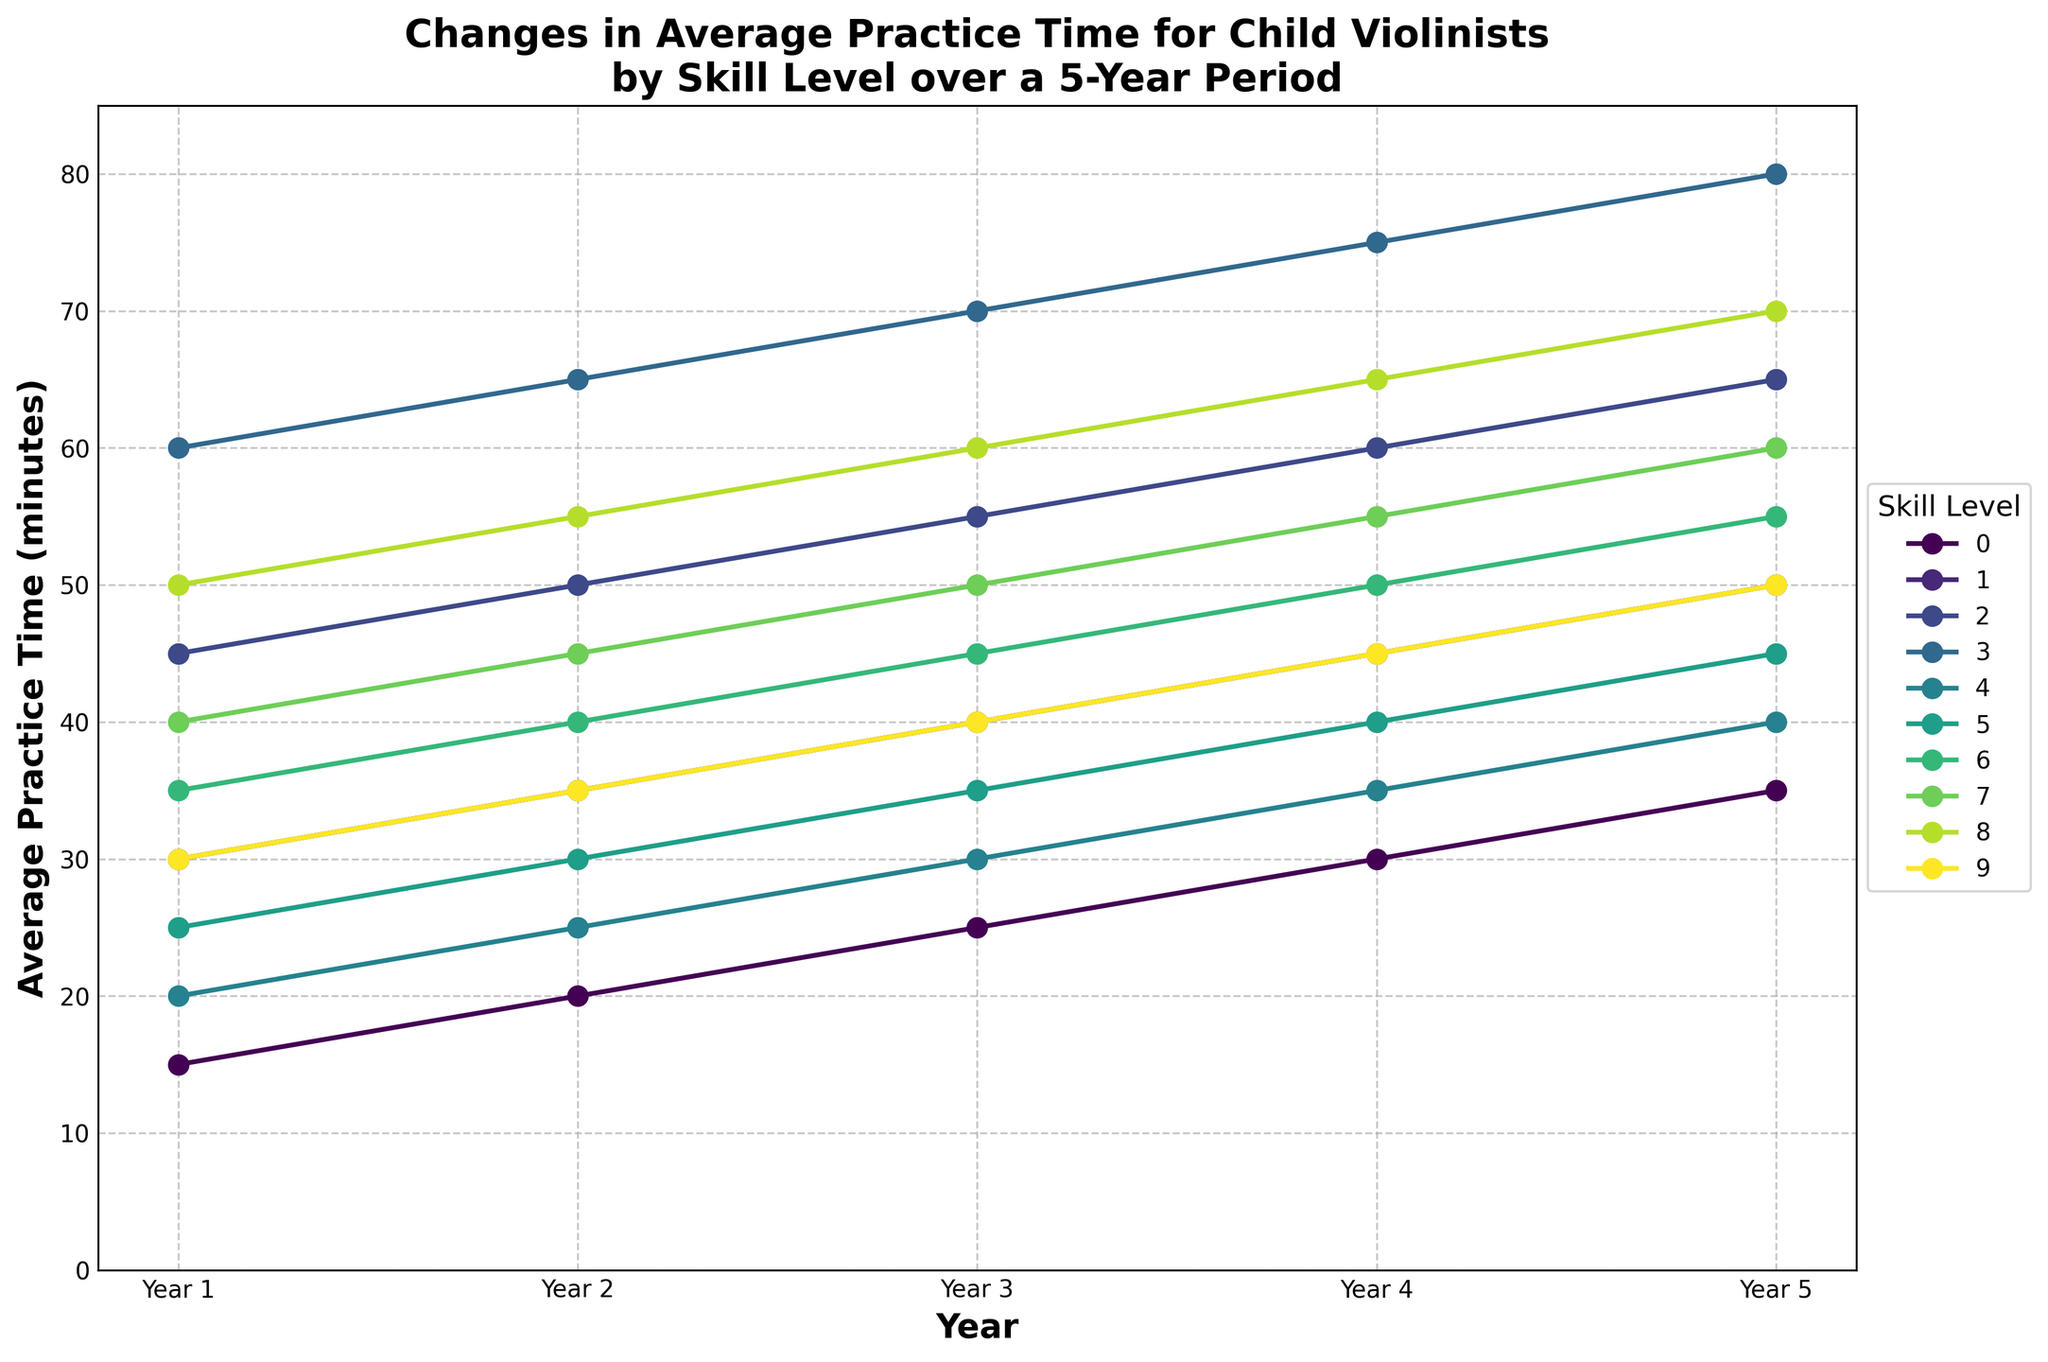What skill level has the steepest increase in practice time over the 5 years? Identify the skill level with the highest difference between the 5th and 1st years. Pre-Professional increases by 20 (from 60 to 80), which is the steepest.
Answer: Pre-Professional Which year shows the largest collective increase in practice time across all levels from the previous year? Calculate the increase for each year across all levels and compare. Year 2 shows the sums of increases: (20-15) + (35-30) + (50-45) + (65-60) + (25-20) + (30-25) + (40-35) + (45-40) + (55-50) + (35-30) = 5 + 5 + 5 + 5 + 5 + 5 + 5 + 5 + 5 + 5 = 50 minutes total, which is the largest.
Answer: Year 2 How does the practice time of a Duet Partner in Year 3 compare to that of an Intermediate-level violinist in Year 5? Look at the practice times for the Duet Partner in Year 3 (40 minutes) and Intermediate-level in Year 5 (50 minutes). Compare 40 to 50.
Answer: Less What is the average practice time for all skill levels in Year 1? Sum all practice times in Year 1 and divide by the number of skill levels (10). (15 + 30 + 45 + 60 + 20 + 25 + 35 + 40 + 50 + 30) / 10 = 35.
Answer: 35 minutes Which skill level had the smallest change in practice time over the 5-year period? Find the difference between the 5th and 1st years for each skill level and identify the smallest. Suzuki Book 1 changes by 20 (from 20 to 40).
Answer: Suzuki Book 1 In which year do both the Advanced and Suzuki Book 3 skill levels have the same practice time? Compare the practice times for Advanced and Suzuki Book 3 across all years. They both have 55 minutes in Year 5.
Answer: Year 5 Which skill level has the highest practice time in Year 3? Identify the practice times for all skill levels in Year 3 and find the highest value. Pre-Professional has the highest with 70 minutes.
Answer: Pre-Professional What is the total increase in practice time for the Suzuki Book 4 skill level over the entire period? Subtract the Year 1 practice time from the Year 5 practice time for Suzuki Book 4. 60 - 40 = 20.
Answer: 20 minutes How does the practice time for Orchestra Level in Year 2 compare to the Intermediate level in Year 4? Look at the practice times for Orchestra Level in Year 2 (55 minutes) and Intermediate-level in Year 4 (45 minutes). Compare 55 to 45.
Answer: More Which year marks the first time the Duet Partner skill level practices more than the Beginner skill level? Identify the first year where the practice time of Duet Partner exceeds Beginner. In Year 2, Duet Partner practices 35 minutes, Beginner practices 20 minutes, which is higher.
Answer: Year 2 